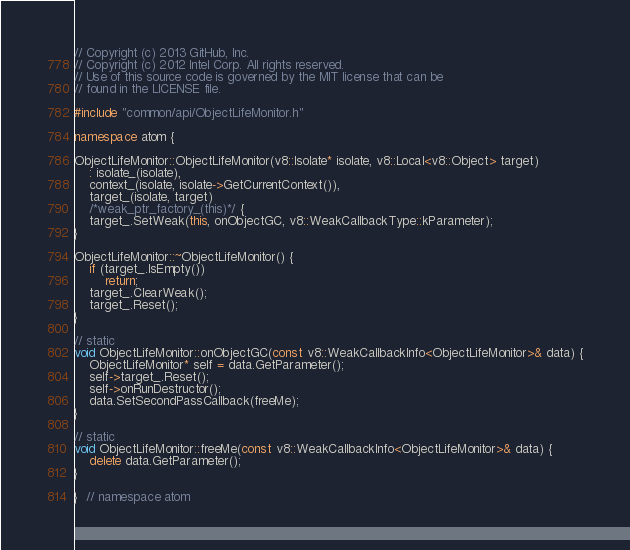<code> <loc_0><loc_0><loc_500><loc_500><_C++_>// Copyright (c) 2013 GitHub, Inc.
// Copyright (c) 2012 Intel Corp. All rights reserved.
// Use of this source code is governed by the MIT license that can be
// found in the LICENSE file.

#include "common/api/ObjectLifeMonitor.h"

namespace atom {

ObjectLifeMonitor::ObjectLifeMonitor(v8::Isolate* isolate, v8::Local<v8::Object> target)
    : isolate_(isolate),
    context_(isolate, isolate->GetCurrentContext()),
    target_(isolate, target)
    /*weak_ptr_factory_(this)*/ {
    target_.SetWeak(this, onObjectGC, v8::WeakCallbackType::kParameter);
}

ObjectLifeMonitor::~ObjectLifeMonitor() {
    if (target_.IsEmpty())
        return;
    target_.ClearWeak();
    target_.Reset();
}

// static
void ObjectLifeMonitor::onObjectGC(const v8::WeakCallbackInfo<ObjectLifeMonitor>& data) {
    ObjectLifeMonitor* self = data.GetParameter();
    self->target_.Reset();
    self->onRunDestructor();
    data.SetSecondPassCallback(freeMe);
}

// static
void ObjectLifeMonitor::freeMe(const v8::WeakCallbackInfo<ObjectLifeMonitor>& data) {
    delete data.GetParameter();
}

}  // namespace atom
</code> 